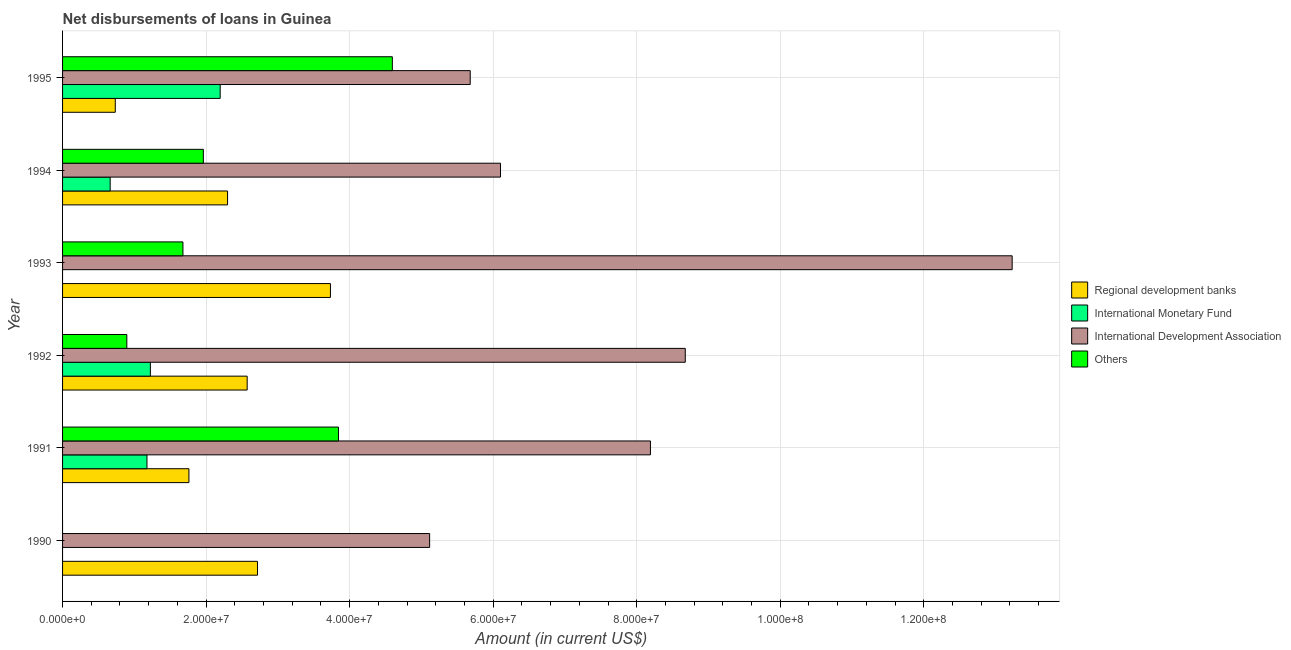How many different coloured bars are there?
Keep it short and to the point. 4. Are the number of bars on each tick of the Y-axis equal?
Keep it short and to the point. No. How many bars are there on the 5th tick from the bottom?
Your answer should be very brief. 4. In how many cases, is the number of bars for a given year not equal to the number of legend labels?
Keep it short and to the point. 2. What is the amount of loan disimbursed by international monetary fund in 1991?
Provide a succinct answer. 1.18e+07. Across all years, what is the maximum amount of loan disimbursed by international monetary fund?
Offer a very short reply. 2.20e+07. What is the total amount of loan disimbursed by international monetary fund in the graph?
Make the answer very short. 5.26e+07. What is the difference between the amount of loan disimbursed by regional development banks in 1990 and that in 1991?
Make the answer very short. 9.55e+06. What is the difference between the amount of loan disimbursed by regional development banks in 1995 and the amount of loan disimbursed by international development association in 1993?
Your answer should be very brief. -1.25e+08. What is the average amount of loan disimbursed by other organisations per year?
Ensure brevity in your answer.  2.16e+07. In the year 1990, what is the difference between the amount of loan disimbursed by international development association and amount of loan disimbursed by regional development banks?
Provide a short and direct response. 2.40e+07. In how many years, is the amount of loan disimbursed by other organisations greater than 100000000 US$?
Provide a succinct answer. 0. What is the ratio of the amount of loan disimbursed by other organisations in 1992 to that in 1995?
Keep it short and to the point. 0.2. Is the difference between the amount of loan disimbursed by other organisations in 1994 and 1995 greater than the difference between the amount of loan disimbursed by international development association in 1994 and 1995?
Give a very brief answer. No. What is the difference between the highest and the second highest amount of loan disimbursed by regional development banks?
Your answer should be compact. 1.02e+07. What is the difference between the highest and the lowest amount of loan disimbursed by international development association?
Give a very brief answer. 8.12e+07. Is the sum of the amount of loan disimbursed by international development association in 1990 and 1995 greater than the maximum amount of loan disimbursed by international monetary fund across all years?
Provide a succinct answer. Yes. How many bars are there?
Your answer should be compact. 21. What is the difference between two consecutive major ticks on the X-axis?
Your answer should be compact. 2.00e+07. Does the graph contain any zero values?
Provide a short and direct response. Yes. Where does the legend appear in the graph?
Ensure brevity in your answer.  Center right. How are the legend labels stacked?
Provide a short and direct response. Vertical. What is the title of the graph?
Make the answer very short. Net disbursements of loans in Guinea. Does "Building human resources" appear as one of the legend labels in the graph?
Give a very brief answer. No. What is the label or title of the X-axis?
Provide a short and direct response. Amount (in current US$). What is the Amount (in current US$) of Regional development banks in 1990?
Your response must be concise. 2.72e+07. What is the Amount (in current US$) in International Development Association in 1990?
Offer a terse response. 5.11e+07. What is the Amount (in current US$) in Others in 1990?
Ensure brevity in your answer.  0. What is the Amount (in current US$) in Regional development banks in 1991?
Give a very brief answer. 1.76e+07. What is the Amount (in current US$) in International Monetary Fund in 1991?
Your answer should be compact. 1.18e+07. What is the Amount (in current US$) in International Development Association in 1991?
Your response must be concise. 8.19e+07. What is the Amount (in current US$) in Others in 1991?
Provide a short and direct response. 3.84e+07. What is the Amount (in current US$) in Regional development banks in 1992?
Offer a terse response. 2.57e+07. What is the Amount (in current US$) in International Monetary Fund in 1992?
Your answer should be compact. 1.22e+07. What is the Amount (in current US$) in International Development Association in 1992?
Give a very brief answer. 8.68e+07. What is the Amount (in current US$) in Others in 1992?
Provide a succinct answer. 8.95e+06. What is the Amount (in current US$) of Regional development banks in 1993?
Give a very brief answer. 3.73e+07. What is the Amount (in current US$) in International Development Association in 1993?
Ensure brevity in your answer.  1.32e+08. What is the Amount (in current US$) in Others in 1993?
Your answer should be compact. 1.68e+07. What is the Amount (in current US$) in Regional development banks in 1994?
Your response must be concise. 2.30e+07. What is the Amount (in current US$) of International Monetary Fund in 1994?
Provide a short and direct response. 6.63e+06. What is the Amount (in current US$) of International Development Association in 1994?
Make the answer very short. 6.10e+07. What is the Amount (in current US$) in Others in 1994?
Provide a short and direct response. 1.96e+07. What is the Amount (in current US$) in Regional development banks in 1995?
Offer a terse response. 7.34e+06. What is the Amount (in current US$) of International Monetary Fund in 1995?
Your answer should be very brief. 2.20e+07. What is the Amount (in current US$) in International Development Association in 1995?
Keep it short and to the point. 5.68e+07. What is the Amount (in current US$) in Others in 1995?
Keep it short and to the point. 4.59e+07. Across all years, what is the maximum Amount (in current US$) of Regional development banks?
Your response must be concise. 3.73e+07. Across all years, what is the maximum Amount (in current US$) of International Monetary Fund?
Make the answer very short. 2.20e+07. Across all years, what is the maximum Amount (in current US$) of International Development Association?
Offer a very short reply. 1.32e+08. Across all years, what is the maximum Amount (in current US$) in Others?
Provide a succinct answer. 4.59e+07. Across all years, what is the minimum Amount (in current US$) in Regional development banks?
Your answer should be compact. 7.34e+06. Across all years, what is the minimum Amount (in current US$) of International Development Association?
Offer a very short reply. 5.11e+07. Across all years, what is the minimum Amount (in current US$) in Others?
Keep it short and to the point. 0. What is the total Amount (in current US$) of Regional development banks in the graph?
Your response must be concise. 1.38e+08. What is the total Amount (in current US$) in International Monetary Fund in the graph?
Give a very brief answer. 5.26e+07. What is the total Amount (in current US$) in International Development Association in the graph?
Your response must be concise. 4.70e+08. What is the total Amount (in current US$) of Others in the graph?
Your answer should be very brief. 1.30e+08. What is the difference between the Amount (in current US$) of Regional development banks in 1990 and that in 1991?
Provide a short and direct response. 9.55e+06. What is the difference between the Amount (in current US$) in International Development Association in 1990 and that in 1991?
Ensure brevity in your answer.  -3.08e+07. What is the difference between the Amount (in current US$) in Regional development banks in 1990 and that in 1992?
Your answer should be very brief. 1.44e+06. What is the difference between the Amount (in current US$) of International Development Association in 1990 and that in 1992?
Provide a short and direct response. -3.56e+07. What is the difference between the Amount (in current US$) in Regional development banks in 1990 and that in 1993?
Keep it short and to the point. -1.02e+07. What is the difference between the Amount (in current US$) of International Development Association in 1990 and that in 1993?
Make the answer very short. -8.12e+07. What is the difference between the Amount (in current US$) of Regional development banks in 1990 and that in 1994?
Your response must be concise. 4.17e+06. What is the difference between the Amount (in current US$) in International Development Association in 1990 and that in 1994?
Keep it short and to the point. -9.88e+06. What is the difference between the Amount (in current US$) in Regional development banks in 1990 and that in 1995?
Your answer should be very brief. 1.98e+07. What is the difference between the Amount (in current US$) in International Development Association in 1990 and that in 1995?
Offer a terse response. -5.66e+06. What is the difference between the Amount (in current US$) of Regional development banks in 1991 and that in 1992?
Your answer should be compact. -8.12e+06. What is the difference between the Amount (in current US$) of International Monetary Fund in 1991 and that in 1992?
Your answer should be compact. -4.73e+05. What is the difference between the Amount (in current US$) in International Development Association in 1991 and that in 1992?
Offer a terse response. -4.86e+06. What is the difference between the Amount (in current US$) in Others in 1991 and that in 1992?
Give a very brief answer. 2.95e+07. What is the difference between the Amount (in current US$) of Regional development banks in 1991 and that in 1993?
Provide a short and direct response. -1.97e+07. What is the difference between the Amount (in current US$) in International Development Association in 1991 and that in 1993?
Your response must be concise. -5.04e+07. What is the difference between the Amount (in current US$) in Others in 1991 and that in 1993?
Ensure brevity in your answer.  2.17e+07. What is the difference between the Amount (in current US$) in Regional development banks in 1991 and that in 1994?
Keep it short and to the point. -5.38e+06. What is the difference between the Amount (in current US$) of International Monetary Fund in 1991 and that in 1994?
Give a very brief answer. 5.13e+06. What is the difference between the Amount (in current US$) in International Development Association in 1991 and that in 1994?
Provide a succinct answer. 2.09e+07. What is the difference between the Amount (in current US$) in Others in 1991 and that in 1994?
Provide a short and direct response. 1.88e+07. What is the difference between the Amount (in current US$) in Regional development banks in 1991 and that in 1995?
Offer a terse response. 1.03e+07. What is the difference between the Amount (in current US$) of International Monetary Fund in 1991 and that in 1995?
Offer a very short reply. -1.02e+07. What is the difference between the Amount (in current US$) in International Development Association in 1991 and that in 1995?
Keep it short and to the point. 2.51e+07. What is the difference between the Amount (in current US$) in Others in 1991 and that in 1995?
Offer a very short reply. -7.51e+06. What is the difference between the Amount (in current US$) in Regional development banks in 1992 and that in 1993?
Offer a terse response. -1.16e+07. What is the difference between the Amount (in current US$) of International Development Association in 1992 and that in 1993?
Your answer should be very brief. -4.55e+07. What is the difference between the Amount (in current US$) of Others in 1992 and that in 1993?
Give a very brief answer. -7.82e+06. What is the difference between the Amount (in current US$) of Regional development banks in 1992 and that in 1994?
Your response must be concise. 2.73e+06. What is the difference between the Amount (in current US$) of International Monetary Fund in 1992 and that in 1994?
Provide a succinct answer. 5.60e+06. What is the difference between the Amount (in current US$) in International Development Association in 1992 and that in 1994?
Your answer should be very brief. 2.57e+07. What is the difference between the Amount (in current US$) of Others in 1992 and that in 1994?
Offer a very short reply. -1.07e+07. What is the difference between the Amount (in current US$) in Regional development banks in 1992 and that in 1995?
Keep it short and to the point. 1.84e+07. What is the difference between the Amount (in current US$) in International Monetary Fund in 1992 and that in 1995?
Offer a terse response. -9.73e+06. What is the difference between the Amount (in current US$) of International Development Association in 1992 and that in 1995?
Offer a very short reply. 3.00e+07. What is the difference between the Amount (in current US$) of Others in 1992 and that in 1995?
Your answer should be compact. -3.70e+07. What is the difference between the Amount (in current US$) in Regional development banks in 1993 and that in 1994?
Give a very brief answer. 1.43e+07. What is the difference between the Amount (in current US$) of International Development Association in 1993 and that in 1994?
Offer a terse response. 7.13e+07. What is the difference between the Amount (in current US$) of Others in 1993 and that in 1994?
Ensure brevity in your answer.  -2.85e+06. What is the difference between the Amount (in current US$) in Regional development banks in 1993 and that in 1995?
Provide a short and direct response. 3.00e+07. What is the difference between the Amount (in current US$) in International Development Association in 1993 and that in 1995?
Ensure brevity in your answer.  7.55e+07. What is the difference between the Amount (in current US$) in Others in 1993 and that in 1995?
Give a very brief answer. -2.92e+07. What is the difference between the Amount (in current US$) in Regional development banks in 1994 and that in 1995?
Provide a short and direct response. 1.56e+07. What is the difference between the Amount (in current US$) of International Monetary Fund in 1994 and that in 1995?
Ensure brevity in your answer.  -1.53e+07. What is the difference between the Amount (in current US$) in International Development Association in 1994 and that in 1995?
Ensure brevity in your answer.  4.22e+06. What is the difference between the Amount (in current US$) of Others in 1994 and that in 1995?
Your response must be concise. -2.63e+07. What is the difference between the Amount (in current US$) in Regional development banks in 1990 and the Amount (in current US$) in International Monetary Fund in 1991?
Give a very brief answer. 1.54e+07. What is the difference between the Amount (in current US$) in Regional development banks in 1990 and the Amount (in current US$) in International Development Association in 1991?
Make the answer very short. -5.48e+07. What is the difference between the Amount (in current US$) in Regional development banks in 1990 and the Amount (in current US$) in Others in 1991?
Make the answer very short. -1.13e+07. What is the difference between the Amount (in current US$) in International Development Association in 1990 and the Amount (in current US$) in Others in 1991?
Your response must be concise. 1.27e+07. What is the difference between the Amount (in current US$) of Regional development banks in 1990 and the Amount (in current US$) of International Monetary Fund in 1992?
Offer a terse response. 1.49e+07. What is the difference between the Amount (in current US$) in Regional development banks in 1990 and the Amount (in current US$) in International Development Association in 1992?
Ensure brevity in your answer.  -5.96e+07. What is the difference between the Amount (in current US$) in Regional development banks in 1990 and the Amount (in current US$) in Others in 1992?
Your response must be concise. 1.82e+07. What is the difference between the Amount (in current US$) of International Development Association in 1990 and the Amount (in current US$) of Others in 1992?
Make the answer very short. 4.22e+07. What is the difference between the Amount (in current US$) in Regional development banks in 1990 and the Amount (in current US$) in International Development Association in 1993?
Your answer should be very brief. -1.05e+08. What is the difference between the Amount (in current US$) of Regional development banks in 1990 and the Amount (in current US$) of Others in 1993?
Your answer should be compact. 1.04e+07. What is the difference between the Amount (in current US$) of International Development Association in 1990 and the Amount (in current US$) of Others in 1993?
Keep it short and to the point. 3.44e+07. What is the difference between the Amount (in current US$) of Regional development banks in 1990 and the Amount (in current US$) of International Monetary Fund in 1994?
Your response must be concise. 2.05e+07. What is the difference between the Amount (in current US$) of Regional development banks in 1990 and the Amount (in current US$) of International Development Association in 1994?
Your response must be concise. -3.39e+07. What is the difference between the Amount (in current US$) in Regional development banks in 1990 and the Amount (in current US$) in Others in 1994?
Keep it short and to the point. 7.54e+06. What is the difference between the Amount (in current US$) in International Development Association in 1990 and the Amount (in current US$) in Others in 1994?
Provide a short and direct response. 3.15e+07. What is the difference between the Amount (in current US$) of Regional development banks in 1990 and the Amount (in current US$) of International Monetary Fund in 1995?
Offer a very short reply. 5.20e+06. What is the difference between the Amount (in current US$) of Regional development banks in 1990 and the Amount (in current US$) of International Development Association in 1995?
Offer a terse response. -2.96e+07. What is the difference between the Amount (in current US$) of Regional development banks in 1990 and the Amount (in current US$) of Others in 1995?
Your answer should be compact. -1.88e+07. What is the difference between the Amount (in current US$) of International Development Association in 1990 and the Amount (in current US$) of Others in 1995?
Provide a short and direct response. 5.20e+06. What is the difference between the Amount (in current US$) of Regional development banks in 1991 and the Amount (in current US$) of International Monetary Fund in 1992?
Provide a succinct answer. 5.37e+06. What is the difference between the Amount (in current US$) of Regional development banks in 1991 and the Amount (in current US$) of International Development Association in 1992?
Offer a terse response. -6.92e+07. What is the difference between the Amount (in current US$) of Regional development banks in 1991 and the Amount (in current US$) of Others in 1992?
Ensure brevity in your answer.  8.65e+06. What is the difference between the Amount (in current US$) in International Monetary Fund in 1991 and the Amount (in current US$) in International Development Association in 1992?
Provide a succinct answer. -7.50e+07. What is the difference between the Amount (in current US$) in International Monetary Fund in 1991 and the Amount (in current US$) in Others in 1992?
Give a very brief answer. 2.81e+06. What is the difference between the Amount (in current US$) in International Development Association in 1991 and the Amount (in current US$) in Others in 1992?
Provide a succinct answer. 7.30e+07. What is the difference between the Amount (in current US$) in Regional development banks in 1991 and the Amount (in current US$) in International Development Association in 1993?
Offer a very short reply. -1.15e+08. What is the difference between the Amount (in current US$) in Regional development banks in 1991 and the Amount (in current US$) in Others in 1993?
Ensure brevity in your answer.  8.35e+05. What is the difference between the Amount (in current US$) in International Monetary Fund in 1991 and the Amount (in current US$) in International Development Association in 1993?
Your response must be concise. -1.21e+08. What is the difference between the Amount (in current US$) in International Monetary Fund in 1991 and the Amount (in current US$) in Others in 1993?
Provide a short and direct response. -5.01e+06. What is the difference between the Amount (in current US$) in International Development Association in 1991 and the Amount (in current US$) in Others in 1993?
Give a very brief answer. 6.51e+07. What is the difference between the Amount (in current US$) of Regional development banks in 1991 and the Amount (in current US$) of International Monetary Fund in 1994?
Give a very brief answer. 1.10e+07. What is the difference between the Amount (in current US$) in Regional development banks in 1991 and the Amount (in current US$) in International Development Association in 1994?
Provide a succinct answer. -4.34e+07. What is the difference between the Amount (in current US$) of Regional development banks in 1991 and the Amount (in current US$) of Others in 1994?
Keep it short and to the point. -2.01e+06. What is the difference between the Amount (in current US$) in International Monetary Fund in 1991 and the Amount (in current US$) in International Development Association in 1994?
Provide a succinct answer. -4.93e+07. What is the difference between the Amount (in current US$) in International Monetary Fund in 1991 and the Amount (in current US$) in Others in 1994?
Your response must be concise. -7.86e+06. What is the difference between the Amount (in current US$) of International Development Association in 1991 and the Amount (in current US$) of Others in 1994?
Your response must be concise. 6.23e+07. What is the difference between the Amount (in current US$) of Regional development banks in 1991 and the Amount (in current US$) of International Monetary Fund in 1995?
Your answer should be compact. -4.36e+06. What is the difference between the Amount (in current US$) of Regional development banks in 1991 and the Amount (in current US$) of International Development Association in 1995?
Make the answer very short. -3.92e+07. What is the difference between the Amount (in current US$) in Regional development banks in 1991 and the Amount (in current US$) in Others in 1995?
Ensure brevity in your answer.  -2.83e+07. What is the difference between the Amount (in current US$) of International Monetary Fund in 1991 and the Amount (in current US$) of International Development Association in 1995?
Your response must be concise. -4.50e+07. What is the difference between the Amount (in current US$) of International Monetary Fund in 1991 and the Amount (in current US$) of Others in 1995?
Give a very brief answer. -3.42e+07. What is the difference between the Amount (in current US$) in International Development Association in 1991 and the Amount (in current US$) in Others in 1995?
Your answer should be compact. 3.60e+07. What is the difference between the Amount (in current US$) of Regional development banks in 1992 and the Amount (in current US$) of International Development Association in 1993?
Provide a short and direct response. -1.07e+08. What is the difference between the Amount (in current US$) of Regional development banks in 1992 and the Amount (in current US$) of Others in 1993?
Ensure brevity in your answer.  8.95e+06. What is the difference between the Amount (in current US$) in International Monetary Fund in 1992 and the Amount (in current US$) in International Development Association in 1993?
Ensure brevity in your answer.  -1.20e+08. What is the difference between the Amount (in current US$) of International Monetary Fund in 1992 and the Amount (in current US$) of Others in 1993?
Ensure brevity in your answer.  -4.54e+06. What is the difference between the Amount (in current US$) in International Development Association in 1992 and the Amount (in current US$) in Others in 1993?
Provide a short and direct response. 7.00e+07. What is the difference between the Amount (in current US$) of Regional development banks in 1992 and the Amount (in current US$) of International Monetary Fund in 1994?
Offer a terse response. 1.91e+07. What is the difference between the Amount (in current US$) in Regional development banks in 1992 and the Amount (in current US$) in International Development Association in 1994?
Give a very brief answer. -3.53e+07. What is the difference between the Amount (in current US$) in Regional development banks in 1992 and the Amount (in current US$) in Others in 1994?
Give a very brief answer. 6.10e+06. What is the difference between the Amount (in current US$) of International Monetary Fund in 1992 and the Amount (in current US$) of International Development Association in 1994?
Your answer should be compact. -4.88e+07. What is the difference between the Amount (in current US$) in International Monetary Fund in 1992 and the Amount (in current US$) in Others in 1994?
Your response must be concise. -7.38e+06. What is the difference between the Amount (in current US$) of International Development Association in 1992 and the Amount (in current US$) of Others in 1994?
Your response must be concise. 6.71e+07. What is the difference between the Amount (in current US$) in Regional development banks in 1992 and the Amount (in current US$) in International Monetary Fund in 1995?
Give a very brief answer. 3.76e+06. What is the difference between the Amount (in current US$) in Regional development banks in 1992 and the Amount (in current US$) in International Development Association in 1995?
Your answer should be very brief. -3.11e+07. What is the difference between the Amount (in current US$) in Regional development banks in 1992 and the Amount (in current US$) in Others in 1995?
Your answer should be compact. -2.02e+07. What is the difference between the Amount (in current US$) of International Monetary Fund in 1992 and the Amount (in current US$) of International Development Association in 1995?
Your answer should be compact. -4.46e+07. What is the difference between the Amount (in current US$) of International Monetary Fund in 1992 and the Amount (in current US$) of Others in 1995?
Make the answer very short. -3.37e+07. What is the difference between the Amount (in current US$) of International Development Association in 1992 and the Amount (in current US$) of Others in 1995?
Your answer should be compact. 4.08e+07. What is the difference between the Amount (in current US$) in Regional development banks in 1993 and the Amount (in current US$) in International Monetary Fund in 1994?
Keep it short and to the point. 3.07e+07. What is the difference between the Amount (in current US$) of Regional development banks in 1993 and the Amount (in current US$) of International Development Association in 1994?
Ensure brevity in your answer.  -2.37e+07. What is the difference between the Amount (in current US$) of Regional development banks in 1993 and the Amount (in current US$) of Others in 1994?
Your answer should be compact. 1.77e+07. What is the difference between the Amount (in current US$) in International Development Association in 1993 and the Amount (in current US$) in Others in 1994?
Offer a very short reply. 1.13e+08. What is the difference between the Amount (in current US$) in Regional development banks in 1993 and the Amount (in current US$) in International Monetary Fund in 1995?
Make the answer very short. 1.54e+07. What is the difference between the Amount (in current US$) in Regional development banks in 1993 and the Amount (in current US$) in International Development Association in 1995?
Ensure brevity in your answer.  -1.95e+07. What is the difference between the Amount (in current US$) of Regional development banks in 1993 and the Amount (in current US$) of Others in 1995?
Offer a very short reply. -8.63e+06. What is the difference between the Amount (in current US$) of International Development Association in 1993 and the Amount (in current US$) of Others in 1995?
Your answer should be compact. 8.64e+07. What is the difference between the Amount (in current US$) in Regional development banks in 1994 and the Amount (in current US$) in International Monetary Fund in 1995?
Ensure brevity in your answer.  1.03e+06. What is the difference between the Amount (in current US$) in Regional development banks in 1994 and the Amount (in current US$) in International Development Association in 1995?
Your answer should be very brief. -3.38e+07. What is the difference between the Amount (in current US$) of Regional development banks in 1994 and the Amount (in current US$) of Others in 1995?
Your response must be concise. -2.30e+07. What is the difference between the Amount (in current US$) of International Monetary Fund in 1994 and the Amount (in current US$) of International Development Association in 1995?
Provide a succinct answer. -5.02e+07. What is the difference between the Amount (in current US$) of International Monetary Fund in 1994 and the Amount (in current US$) of Others in 1995?
Ensure brevity in your answer.  -3.93e+07. What is the difference between the Amount (in current US$) of International Development Association in 1994 and the Amount (in current US$) of Others in 1995?
Provide a short and direct response. 1.51e+07. What is the average Amount (in current US$) in Regional development banks per year?
Provide a short and direct response. 2.30e+07. What is the average Amount (in current US$) of International Monetary Fund per year?
Offer a very short reply. 8.76e+06. What is the average Amount (in current US$) of International Development Association per year?
Make the answer very short. 7.83e+07. What is the average Amount (in current US$) of Others per year?
Offer a very short reply. 2.16e+07. In the year 1990, what is the difference between the Amount (in current US$) of Regional development banks and Amount (in current US$) of International Development Association?
Offer a very short reply. -2.40e+07. In the year 1991, what is the difference between the Amount (in current US$) of Regional development banks and Amount (in current US$) of International Monetary Fund?
Keep it short and to the point. 5.84e+06. In the year 1991, what is the difference between the Amount (in current US$) in Regional development banks and Amount (in current US$) in International Development Association?
Provide a short and direct response. -6.43e+07. In the year 1991, what is the difference between the Amount (in current US$) of Regional development banks and Amount (in current US$) of Others?
Keep it short and to the point. -2.08e+07. In the year 1991, what is the difference between the Amount (in current US$) in International Monetary Fund and Amount (in current US$) in International Development Association?
Your answer should be compact. -7.01e+07. In the year 1991, what is the difference between the Amount (in current US$) of International Monetary Fund and Amount (in current US$) of Others?
Offer a very short reply. -2.67e+07. In the year 1991, what is the difference between the Amount (in current US$) of International Development Association and Amount (in current US$) of Others?
Provide a short and direct response. 4.35e+07. In the year 1992, what is the difference between the Amount (in current US$) in Regional development banks and Amount (in current US$) in International Monetary Fund?
Your answer should be compact. 1.35e+07. In the year 1992, what is the difference between the Amount (in current US$) of Regional development banks and Amount (in current US$) of International Development Association?
Your answer should be compact. -6.10e+07. In the year 1992, what is the difference between the Amount (in current US$) in Regional development banks and Amount (in current US$) in Others?
Offer a terse response. 1.68e+07. In the year 1992, what is the difference between the Amount (in current US$) in International Monetary Fund and Amount (in current US$) in International Development Association?
Make the answer very short. -7.45e+07. In the year 1992, what is the difference between the Amount (in current US$) of International Monetary Fund and Amount (in current US$) of Others?
Your answer should be very brief. 3.28e+06. In the year 1992, what is the difference between the Amount (in current US$) of International Development Association and Amount (in current US$) of Others?
Your answer should be compact. 7.78e+07. In the year 1993, what is the difference between the Amount (in current US$) of Regional development banks and Amount (in current US$) of International Development Association?
Offer a very short reply. -9.50e+07. In the year 1993, what is the difference between the Amount (in current US$) in Regional development banks and Amount (in current US$) in Others?
Ensure brevity in your answer.  2.06e+07. In the year 1993, what is the difference between the Amount (in current US$) of International Development Association and Amount (in current US$) of Others?
Ensure brevity in your answer.  1.16e+08. In the year 1994, what is the difference between the Amount (in current US$) of Regional development banks and Amount (in current US$) of International Monetary Fund?
Ensure brevity in your answer.  1.64e+07. In the year 1994, what is the difference between the Amount (in current US$) in Regional development banks and Amount (in current US$) in International Development Association?
Ensure brevity in your answer.  -3.80e+07. In the year 1994, what is the difference between the Amount (in current US$) in Regional development banks and Amount (in current US$) in Others?
Keep it short and to the point. 3.37e+06. In the year 1994, what is the difference between the Amount (in current US$) of International Monetary Fund and Amount (in current US$) of International Development Association?
Make the answer very short. -5.44e+07. In the year 1994, what is the difference between the Amount (in current US$) in International Monetary Fund and Amount (in current US$) in Others?
Keep it short and to the point. -1.30e+07. In the year 1994, what is the difference between the Amount (in current US$) of International Development Association and Amount (in current US$) of Others?
Provide a short and direct response. 4.14e+07. In the year 1995, what is the difference between the Amount (in current US$) in Regional development banks and Amount (in current US$) in International Monetary Fund?
Provide a short and direct response. -1.46e+07. In the year 1995, what is the difference between the Amount (in current US$) of Regional development banks and Amount (in current US$) of International Development Association?
Ensure brevity in your answer.  -4.95e+07. In the year 1995, what is the difference between the Amount (in current US$) in Regional development banks and Amount (in current US$) in Others?
Keep it short and to the point. -3.86e+07. In the year 1995, what is the difference between the Amount (in current US$) of International Monetary Fund and Amount (in current US$) of International Development Association?
Ensure brevity in your answer.  -3.48e+07. In the year 1995, what is the difference between the Amount (in current US$) of International Monetary Fund and Amount (in current US$) of Others?
Your response must be concise. -2.40e+07. In the year 1995, what is the difference between the Amount (in current US$) of International Development Association and Amount (in current US$) of Others?
Make the answer very short. 1.08e+07. What is the ratio of the Amount (in current US$) of Regional development banks in 1990 to that in 1991?
Provide a short and direct response. 1.54. What is the ratio of the Amount (in current US$) in International Development Association in 1990 to that in 1991?
Make the answer very short. 0.62. What is the ratio of the Amount (in current US$) of Regional development banks in 1990 to that in 1992?
Offer a very short reply. 1.06. What is the ratio of the Amount (in current US$) of International Development Association in 1990 to that in 1992?
Offer a very short reply. 0.59. What is the ratio of the Amount (in current US$) of Regional development banks in 1990 to that in 1993?
Your answer should be compact. 0.73. What is the ratio of the Amount (in current US$) of International Development Association in 1990 to that in 1993?
Offer a very short reply. 0.39. What is the ratio of the Amount (in current US$) in Regional development banks in 1990 to that in 1994?
Keep it short and to the point. 1.18. What is the ratio of the Amount (in current US$) in International Development Association in 1990 to that in 1994?
Offer a terse response. 0.84. What is the ratio of the Amount (in current US$) in Regional development banks in 1990 to that in 1995?
Keep it short and to the point. 3.7. What is the ratio of the Amount (in current US$) of International Development Association in 1990 to that in 1995?
Your response must be concise. 0.9. What is the ratio of the Amount (in current US$) of Regional development banks in 1991 to that in 1992?
Provide a short and direct response. 0.68. What is the ratio of the Amount (in current US$) of International Monetary Fund in 1991 to that in 1992?
Your response must be concise. 0.96. What is the ratio of the Amount (in current US$) of International Development Association in 1991 to that in 1992?
Offer a very short reply. 0.94. What is the ratio of the Amount (in current US$) of Others in 1991 to that in 1992?
Ensure brevity in your answer.  4.29. What is the ratio of the Amount (in current US$) in Regional development banks in 1991 to that in 1993?
Keep it short and to the point. 0.47. What is the ratio of the Amount (in current US$) of International Development Association in 1991 to that in 1993?
Give a very brief answer. 0.62. What is the ratio of the Amount (in current US$) in Others in 1991 to that in 1993?
Give a very brief answer. 2.29. What is the ratio of the Amount (in current US$) of Regional development banks in 1991 to that in 1994?
Your answer should be compact. 0.77. What is the ratio of the Amount (in current US$) in International Monetary Fund in 1991 to that in 1994?
Offer a terse response. 1.77. What is the ratio of the Amount (in current US$) in International Development Association in 1991 to that in 1994?
Ensure brevity in your answer.  1.34. What is the ratio of the Amount (in current US$) in Others in 1991 to that in 1994?
Offer a very short reply. 1.96. What is the ratio of the Amount (in current US$) in Regional development banks in 1991 to that in 1995?
Offer a very short reply. 2.4. What is the ratio of the Amount (in current US$) in International Monetary Fund in 1991 to that in 1995?
Make the answer very short. 0.54. What is the ratio of the Amount (in current US$) of International Development Association in 1991 to that in 1995?
Make the answer very short. 1.44. What is the ratio of the Amount (in current US$) in Others in 1991 to that in 1995?
Your response must be concise. 0.84. What is the ratio of the Amount (in current US$) of Regional development banks in 1992 to that in 1993?
Your answer should be compact. 0.69. What is the ratio of the Amount (in current US$) of International Development Association in 1992 to that in 1993?
Offer a terse response. 0.66. What is the ratio of the Amount (in current US$) of Others in 1992 to that in 1993?
Keep it short and to the point. 0.53. What is the ratio of the Amount (in current US$) of Regional development banks in 1992 to that in 1994?
Your answer should be very brief. 1.12. What is the ratio of the Amount (in current US$) in International Monetary Fund in 1992 to that in 1994?
Provide a succinct answer. 1.84. What is the ratio of the Amount (in current US$) in International Development Association in 1992 to that in 1994?
Provide a short and direct response. 1.42. What is the ratio of the Amount (in current US$) in Others in 1992 to that in 1994?
Make the answer very short. 0.46. What is the ratio of the Amount (in current US$) in Regional development banks in 1992 to that in 1995?
Offer a terse response. 3.5. What is the ratio of the Amount (in current US$) in International Monetary Fund in 1992 to that in 1995?
Make the answer very short. 0.56. What is the ratio of the Amount (in current US$) in International Development Association in 1992 to that in 1995?
Ensure brevity in your answer.  1.53. What is the ratio of the Amount (in current US$) of Others in 1992 to that in 1995?
Your response must be concise. 0.19. What is the ratio of the Amount (in current US$) in Regional development banks in 1993 to that in 1994?
Your answer should be compact. 1.62. What is the ratio of the Amount (in current US$) in International Development Association in 1993 to that in 1994?
Keep it short and to the point. 2.17. What is the ratio of the Amount (in current US$) of Others in 1993 to that in 1994?
Ensure brevity in your answer.  0.85. What is the ratio of the Amount (in current US$) of Regional development banks in 1993 to that in 1995?
Make the answer very short. 5.08. What is the ratio of the Amount (in current US$) in International Development Association in 1993 to that in 1995?
Give a very brief answer. 2.33. What is the ratio of the Amount (in current US$) of Others in 1993 to that in 1995?
Your response must be concise. 0.36. What is the ratio of the Amount (in current US$) of Regional development banks in 1994 to that in 1995?
Your answer should be very brief. 3.13. What is the ratio of the Amount (in current US$) of International Monetary Fund in 1994 to that in 1995?
Make the answer very short. 0.3. What is the ratio of the Amount (in current US$) in International Development Association in 1994 to that in 1995?
Give a very brief answer. 1.07. What is the ratio of the Amount (in current US$) in Others in 1994 to that in 1995?
Make the answer very short. 0.43. What is the difference between the highest and the second highest Amount (in current US$) of Regional development banks?
Ensure brevity in your answer.  1.02e+07. What is the difference between the highest and the second highest Amount (in current US$) in International Monetary Fund?
Provide a short and direct response. 9.73e+06. What is the difference between the highest and the second highest Amount (in current US$) of International Development Association?
Offer a very short reply. 4.55e+07. What is the difference between the highest and the second highest Amount (in current US$) of Others?
Provide a succinct answer. 7.51e+06. What is the difference between the highest and the lowest Amount (in current US$) of Regional development banks?
Keep it short and to the point. 3.00e+07. What is the difference between the highest and the lowest Amount (in current US$) in International Monetary Fund?
Ensure brevity in your answer.  2.20e+07. What is the difference between the highest and the lowest Amount (in current US$) of International Development Association?
Offer a terse response. 8.12e+07. What is the difference between the highest and the lowest Amount (in current US$) of Others?
Give a very brief answer. 4.59e+07. 